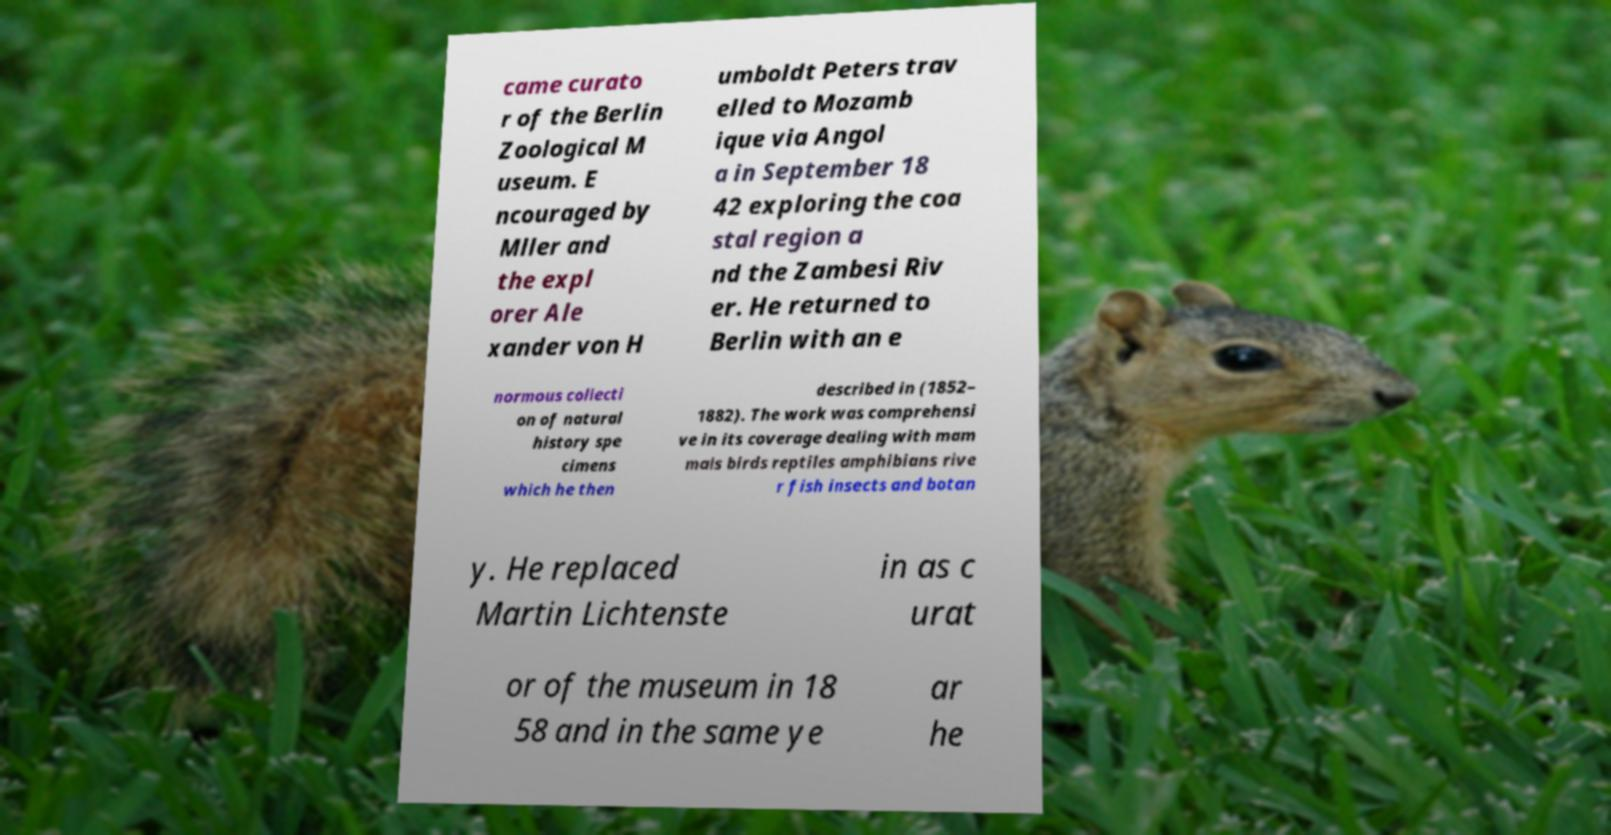Please identify and transcribe the text found in this image. came curato r of the Berlin Zoological M useum. E ncouraged by Mller and the expl orer Ale xander von H umboldt Peters trav elled to Mozamb ique via Angol a in September 18 42 exploring the coa stal region a nd the Zambesi Riv er. He returned to Berlin with an e normous collecti on of natural history spe cimens which he then described in (1852– 1882). The work was comprehensi ve in its coverage dealing with mam mals birds reptiles amphibians rive r fish insects and botan y. He replaced Martin Lichtenste in as c urat or of the museum in 18 58 and in the same ye ar he 